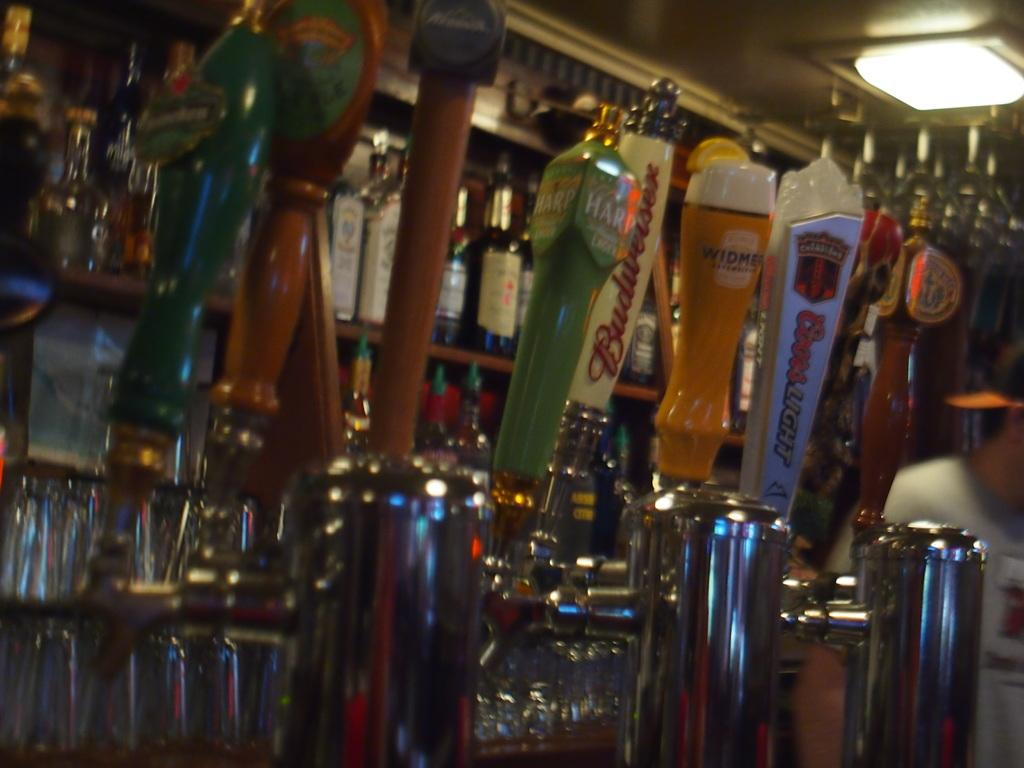<image>
Share a concise interpretation of the image provided. A series of bar beer taps including Budweiser. 